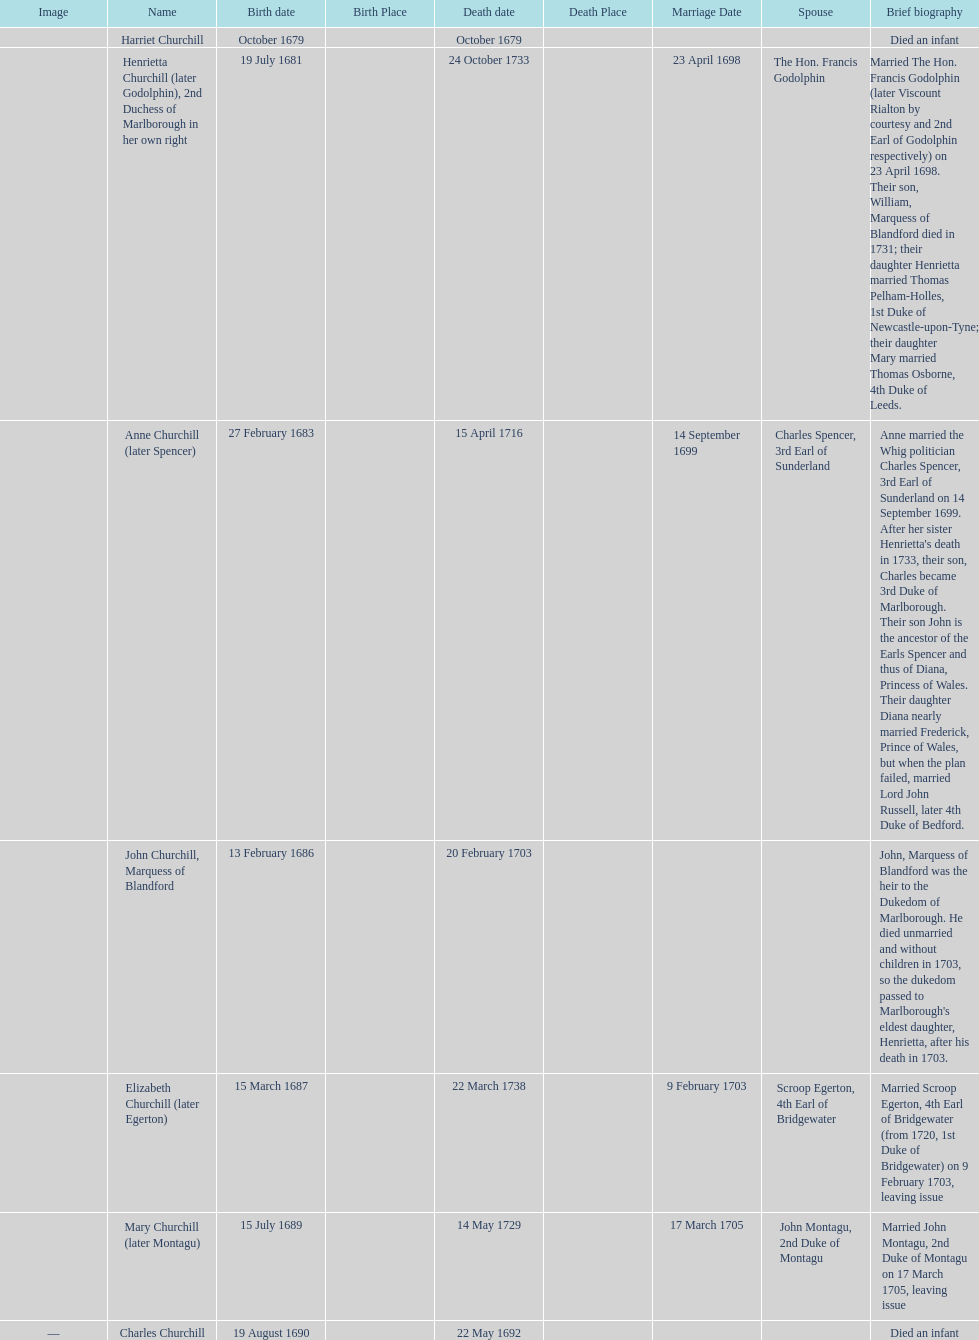What is the total number of children listed? 7. 